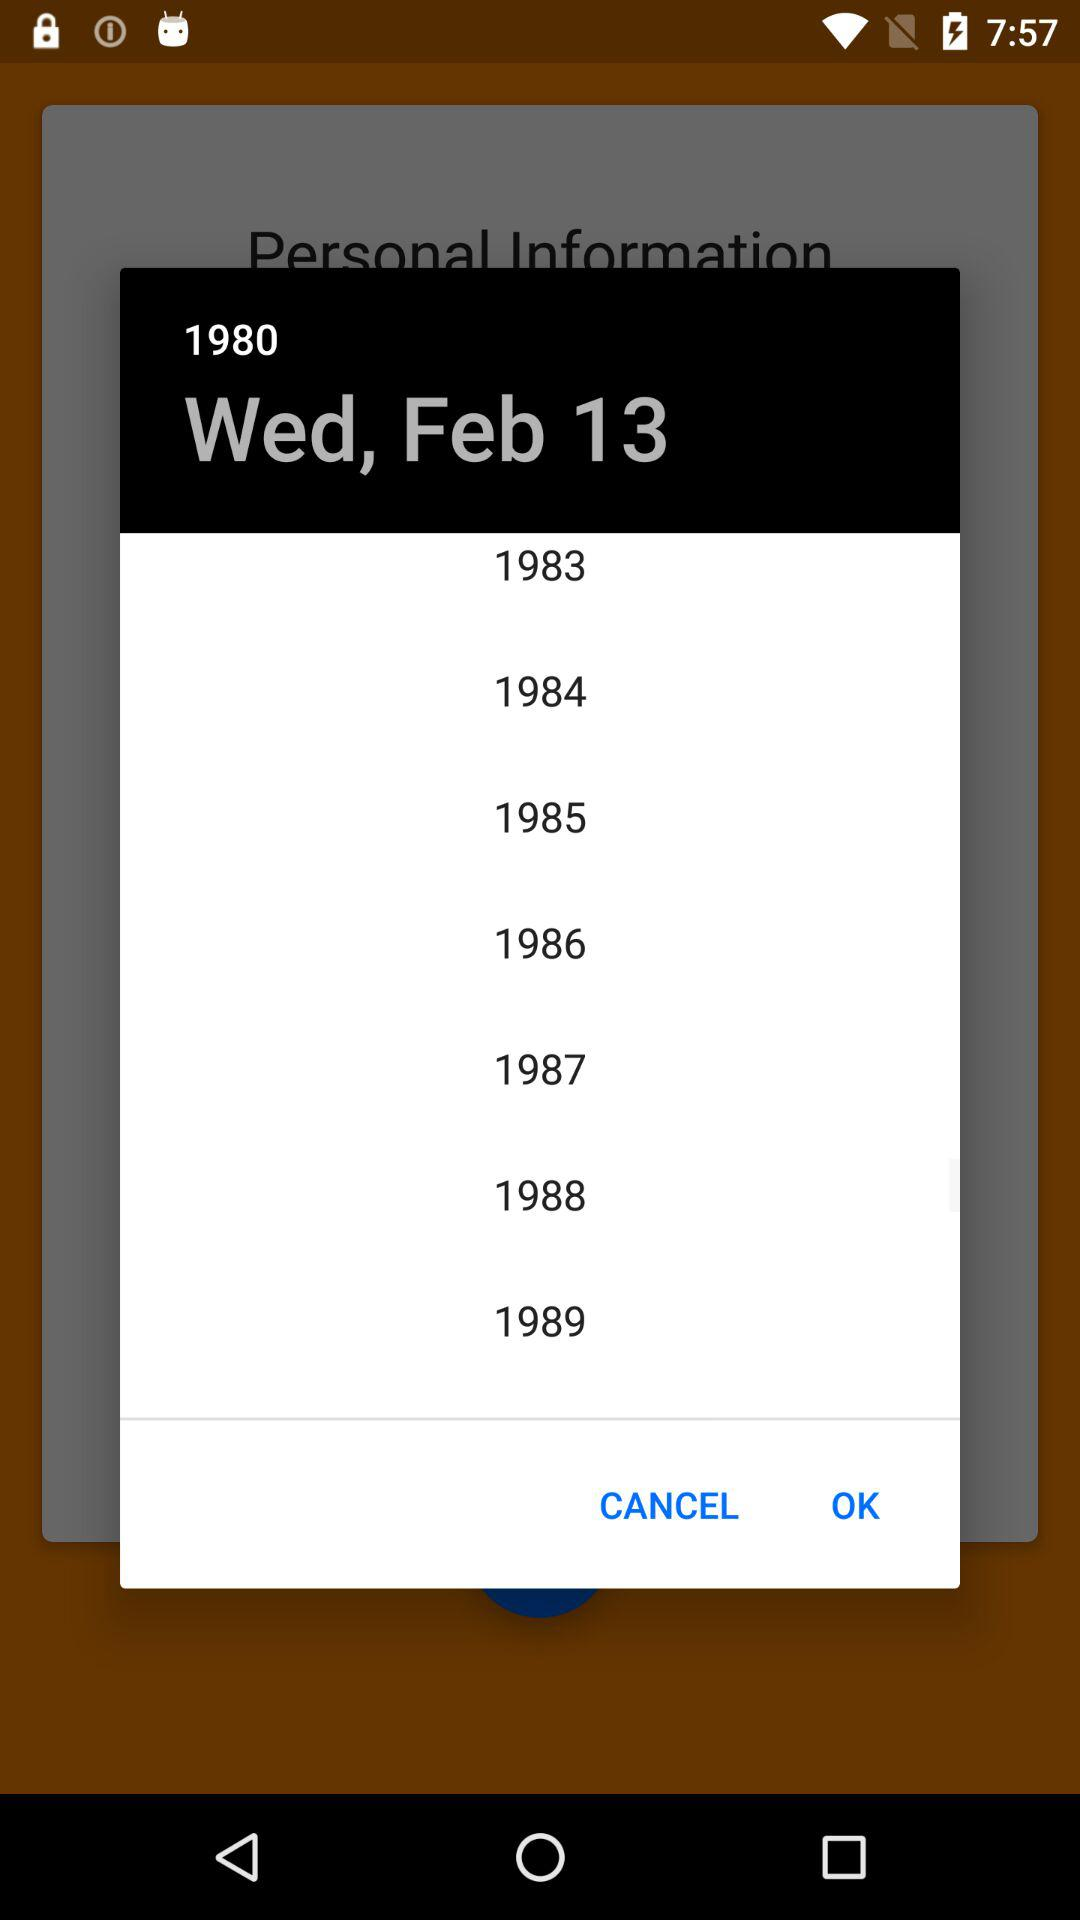Which date is selected? The selected date is Wednesday, February 13, 1980. 